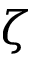<formula> <loc_0><loc_0><loc_500><loc_500>\zeta</formula> 